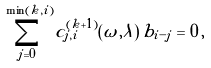Convert formula to latex. <formula><loc_0><loc_0><loc_500><loc_500>\sum _ { j = 0 } ^ { \min ( k , i ) } c _ { j , i } ^ { ( k + 1 ) } ( \omega , \lambda ) \, b _ { i - j } = 0 \, ,</formula> 